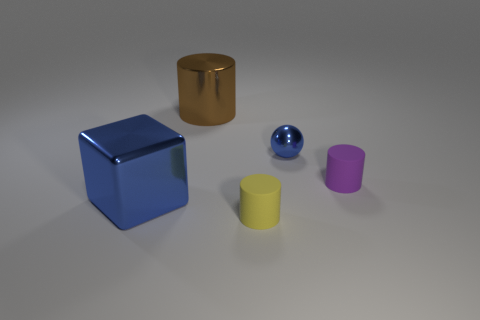Is the size of the matte cylinder that is in front of the tiny purple cylinder the same as the blue metallic object to the left of the tiny yellow thing?
Provide a succinct answer. No. There is a tiny cylinder in front of the small cylinder behind the tiny yellow rubber object; what is its material?
Provide a succinct answer. Rubber. The purple thing is what shape?
Provide a succinct answer. Cylinder. What is the material of the large brown thing that is the same shape as the small yellow thing?
Offer a very short reply. Metal. How many metallic spheres have the same size as the brown object?
Make the answer very short. 0. There is a small rubber thing that is right of the tiny yellow cylinder; are there any shiny things that are left of it?
Provide a short and direct response. Yes. What number of brown things are shiny balls or shiny things?
Offer a terse response. 1. The big cylinder has what color?
Provide a succinct answer. Brown. There is a brown object that is the same material as the tiny ball; what size is it?
Keep it short and to the point. Large. What number of other metal things are the same shape as the tiny purple thing?
Offer a terse response. 1. 